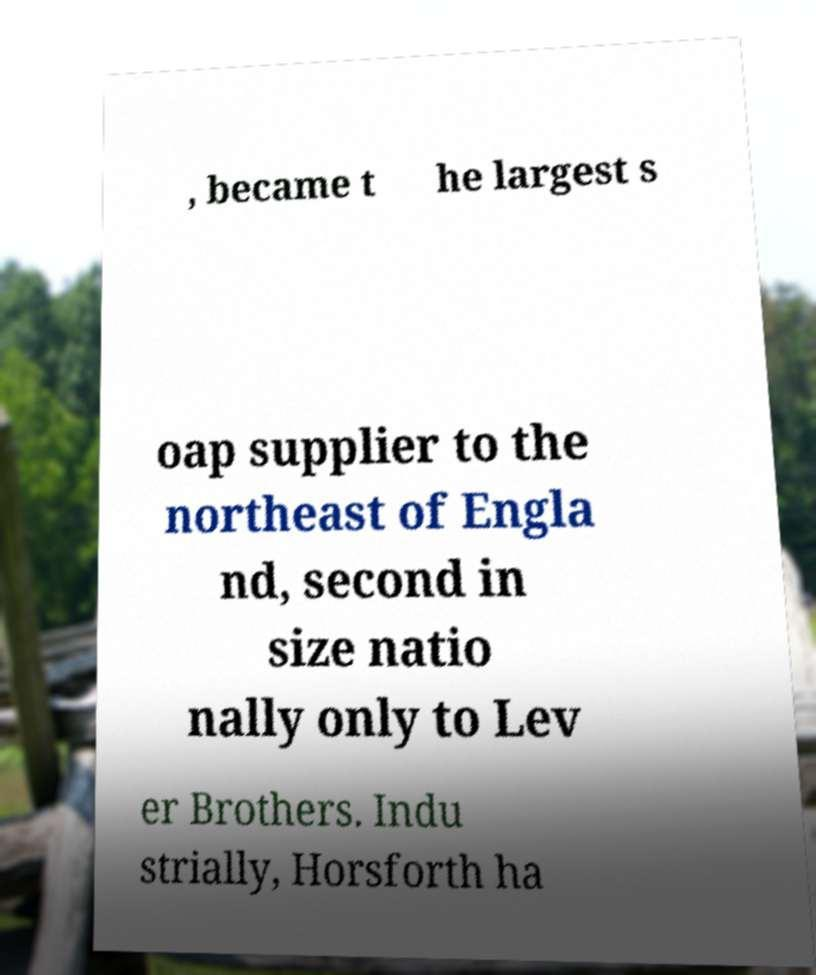Can you read and provide the text displayed in the image?This photo seems to have some interesting text. Can you extract and type it out for me? , became t he largest s oap supplier to the northeast of Engla nd, second in size natio nally only to Lev er Brothers. Indu strially, Horsforth ha 